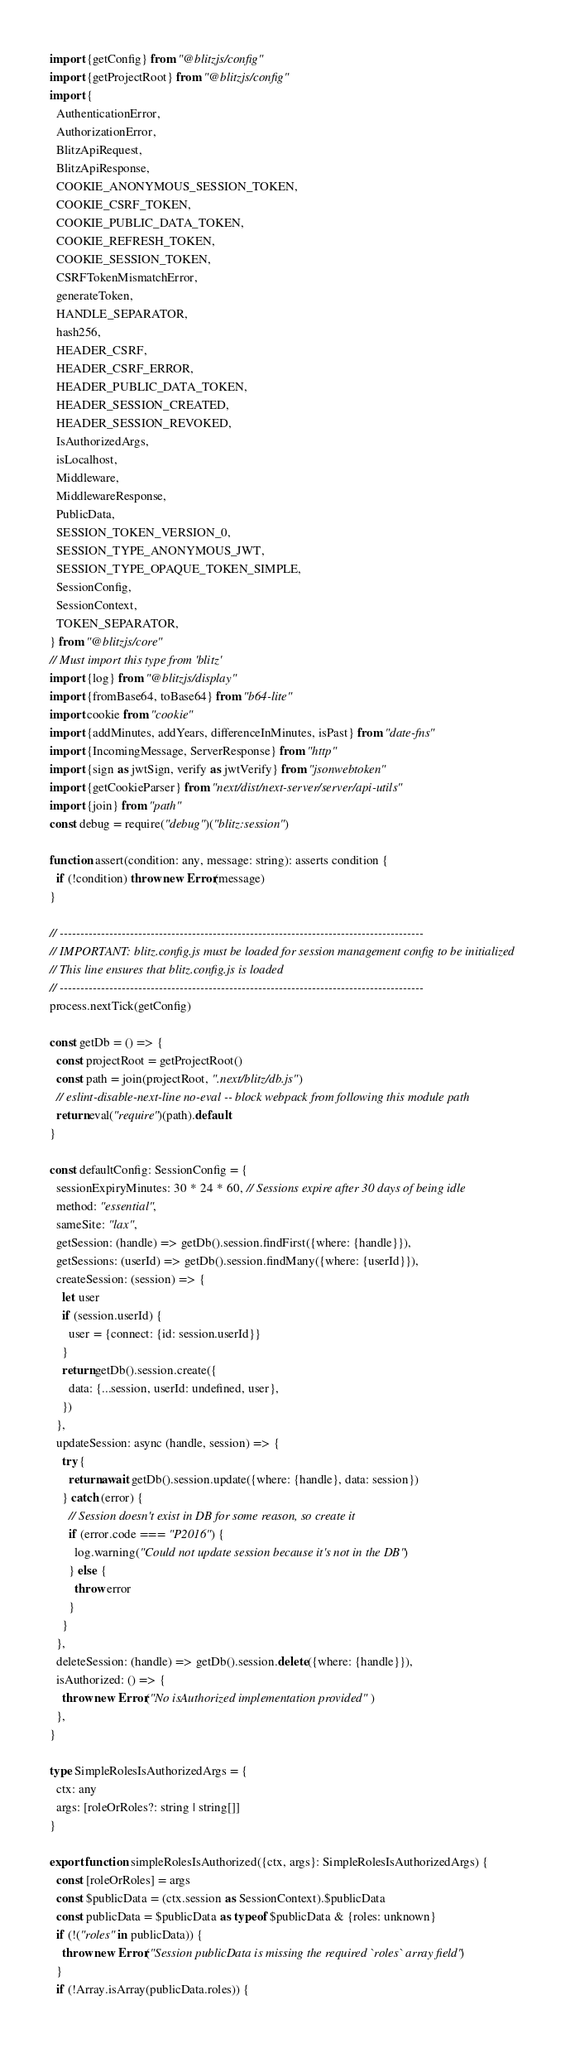Convert code to text. <code><loc_0><loc_0><loc_500><loc_500><_TypeScript_>import {getConfig} from "@blitzjs/config"
import {getProjectRoot} from "@blitzjs/config"
import {
  AuthenticationError,
  AuthorizationError,
  BlitzApiRequest,
  BlitzApiResponse,
  COOKIE_ANONYMOUS_SESSION_TOKEN,
  COOKIE_CSRF_TOKEN,
  COOKIE_PUBLIC_DATA_TOKEN,
  COOKIE_REFRESH_TOKEN,
  COOKIE_SESSION_TOKEN,
  CSRFTokenMismatchError,
  generateToken,
  HANDLE_SEPARATOR,
  hash256,
  HEADER_CSRF,
  HEADER_CSRF_ERROR,
  HEADER_PUBLIC_DATA_TOKEN,
  HEADER_SESSION_CREATED,
  HEADER_SESSION_REVOKED,
  IsAuthorizedArgs,
  isLocalhost,
  Middleware,
  MiddlewareResponse,
  PublicData,
  SESSION_TOKEN_VERSION_0,
  SESSION_TYPE_ANONYMOUS_JWT,
  SESSION_TYPE_OPAQUE_TOKEN_SIMPLE,
  SessionConfig,
  SessionContext,
  TOKEN_SEPARATOR,
} from "@blitzjs/core"
// Must import this type from 'blitz'
import {log} from "@blitzjs/display"
import {fromBase64, toBase64} from "b64-lite"
import cookie from "cookie"
import {addMinutes, addYears, differenceInMinutes, isPast} from "date-fns"
import {IncomingMessage, ServerResponse} from "http"
import {sign as jwtSign, verify as jwtVerify} from "jsonwebtoken"
import {getCookieParser} from "next/dist/next-server/server/api-utils"
import {join} from "path"
const debug = require("debug")("blitz:session")

function assert(condition: any, message: string): asserts condition {
  if (!condition) throw new Error(message)
}

// ----------------------------------------------------------------------------------------
// IMPORTANT: blitz.config.js must be loaded for session management config to be initialized
// This line ensures that blitz.config.js is loaded
// ----------------------------------------------------------------------------------------
process.nextTick(getConfig)

const getDb = () => {
  const projectRoot = getProjectRoot()
  const path = join(projectRoot, ".next/blitz/db.js")
  // eslint-disable-next-line no-eval -- block webpack from following this module path
  return eval("require")(path).default
}

const defaultConfig: SessionConfig = {
  sessionExpiryMinutes: 30 * 24 * 60, // Sessions expire after 30 days of being idle
  method: "essential",
  sameSite: "lax",
  getSession: (handle) => getDb().session.findFirst({where: {handle}}),
  getSessions: (userId) => getDb().session.findMany({where: {userId}}),
  createSession: (session) => {
    let user
    if (session.userId) {
      user = {connect: {id: session.userId}}
    }
    return getDb().session.create({
      data: {...session, userId: undefined, user},
    })
  },
  updateSession: async (handle, session) => {
    try {
      return await getDb().session.update({where: {handle}, data: session})
    } catch (error) {
      // Session doesn't exist in DB for some reason, so create it
      if (error.code === "P2016") {
        log.warning("Could not update session because it's not in the DB")
      } else {
        throw error
      }
    }
  },
  deleteSession: (handle) => getDb().session.delete({where: {handle}}),
  isAuthorized: () => {
    throw new Error("No isAuthorized implementation provided")
  },
}

type SimpleRolesIsAuthorizedArgs = {
  ctx: any
  args: [roleOrRoles?: string | string[]]
}

export function simpleRolesIsAuthorized({ctx, args}: SimpleRolesIsAuthorizedArgs) {
  const [roleOrRoles] = args
  const $publicData = (ctx.session as SessionContext).$publicData
  const publicData = $publicData as typeof $publicData & {roles: unknown}
  if (!("roles" in publicData)) {
    throw new Error("Session publicData is missing the required `roles` array field")
  }
  if (!Array.isArray(publicData.roles)) {</code> 